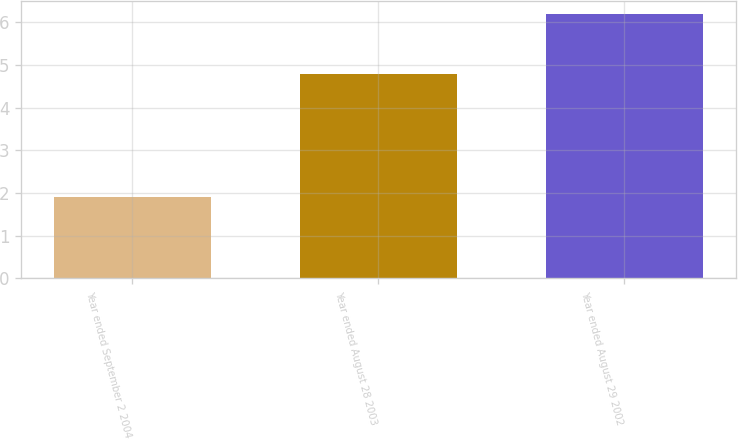<chart> <loc_0><loc_0><loc_500><loc_500><bar_chart><fcel>Year ended September 2 2004<fcel>Year ended August 28 2003<fcel>Year ended August 29 2002<nl><fcel>1.9<fcel>4.8<fcel>6.2<nl></chart> 